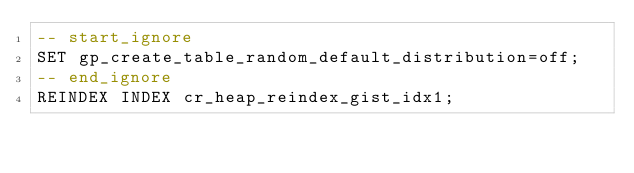<code> <loc_0><loc_0><loc_500><loc_500><_SQL_>-- start_ignore
SET gp_create_table_random_default_distribution=off;
-- end_ignore
REINDEX INDEX cr_heap_reindex_gist_idx1;
</code> 